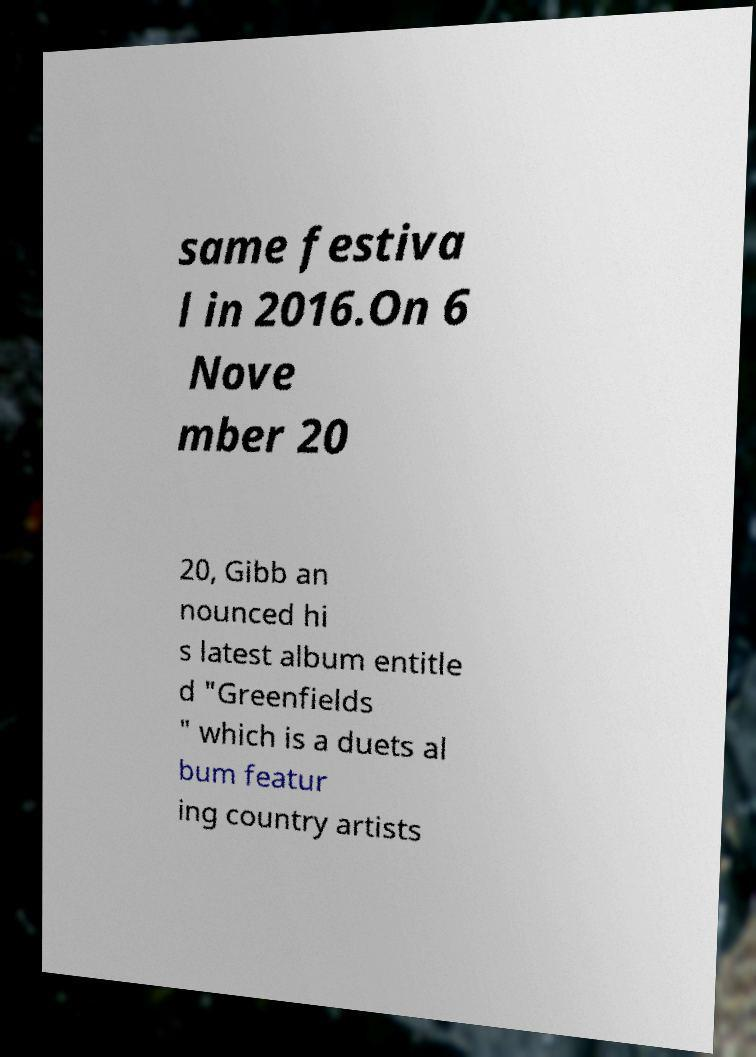There's text embedded in this image that I need extracted. Can you transcribe it verbatim? same festiva l in 2016.On 6 Nove mber 20 20, Gibb an nounced hi s latest album entitle d "Greenfields " which is a duets al bum featur ing country artists 